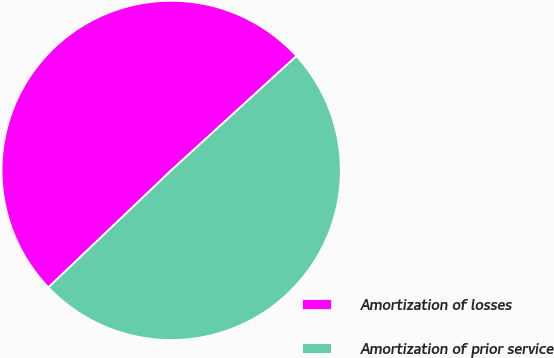<chart> <loc_0><loc_0><loc_500><loc_500><pie_chart><fcel>Amortization of losses<fcel>Amortization of prior service<nl><fcel>50.34%<fcel>49.66%<nl></chart> 